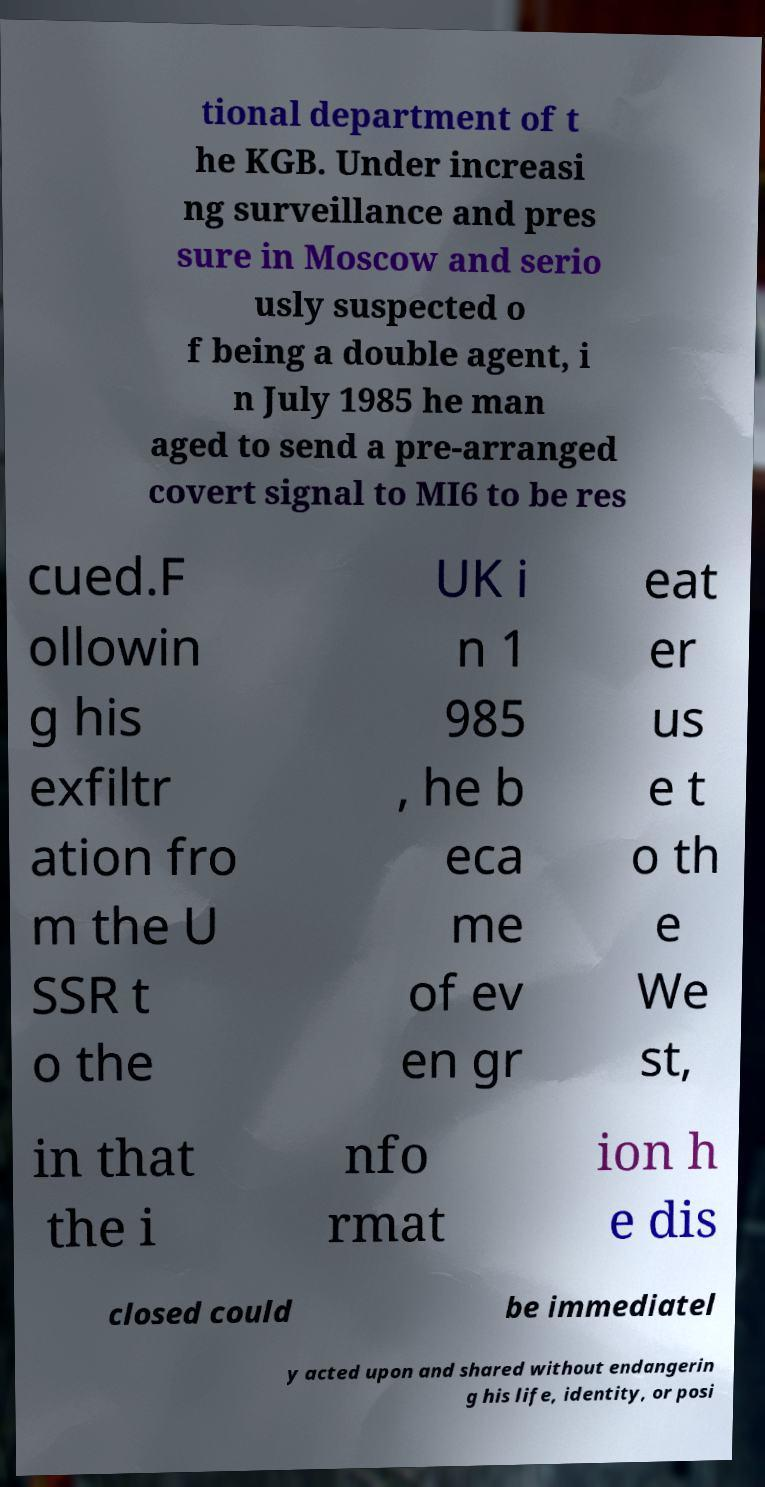There's text embedded in this image that I need extracted. Can you transcribe it verbatim? tional department of t he KGB. Under increasi ng surveillance and pres sure in Moscow and serio usly suspected o f being a double agent, i n July 1985 he man aged to send a pre-arranged covert signal to MI6 to be res cued.F ollowin g his exfiltr ation fro m the U SSR t o the UK i n 1 985 , he b eca me of ev en gr eat er us e t o th e We st, in that the i nfo rmat ion h e dis closed could be immediatel y acted upon and shared without endangerin g his life, identity, or posi 